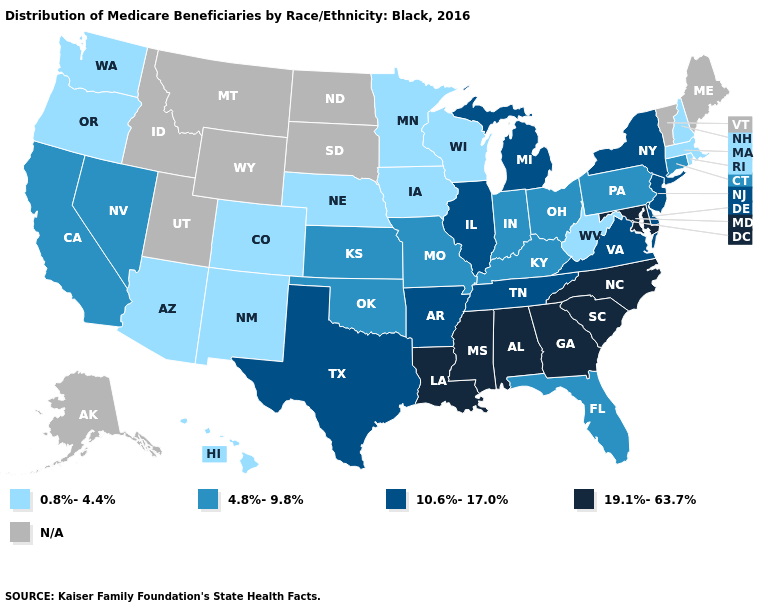Which states have the highest value in the USA?
Write a very short answer. Alabama, Georgia, Louisiana, Maryland, Mississippi, North Carolina, South Carolina. Does Arkansas have the highest value in the South?
Write a very short answer. No. Name the states that have a value in the range 19.1%-63.7%?
Short answer required. Alabama, Georgia, Louisiana, Maryland, Mississippi, North Carolina, South Carolina. What is the value of Wyoming?
Give a very brief answer. N/A. Does Arkansas have the lowest value in the South?
Give a very brief answer. No. Among the states that border Mississippi , does Arkansas have the lowest value?
Give a very brief answer. Yes. Name the states that have a value in the range 0.8%-4.4%?
Keep it brief. Arizona, Colorado, Hawaii, Iowa, Massachusetts, Minnesota, Nebraska, New Hampshire, New Mexico, Oregon, Rhode Island, Washington, West Virginia, Wisconsin. What is the highest value in the USA?
Short answer required. 19.1%-63.7%. Name the states that have a value in the range 4.8%-9.8%?
Keep it brief. California, Connecticut, Florida, Indiana, Kansas, Kentucky, Missouri, Nevada, Ohio, Oklahoma, Pennsylvania. Which states have the highest value in the USA?
Quick response, please. Alabama, Georgia, Louisiana, Maryland, Mississippi, North Carolina, South Carolina. Among the states that border Texas , does New Mexico have the lowest value?
Short answer required. Yes. What is the highest value in the USA?
Short answer required. 19.1%-63.7%. Name the states that have a value in the range N/A?
Quick response, please. Alaska, Idaho, Maine, Montana, North Dakota, South Dakota, Utah, Vermont, Wyoming. Name the states that have a value in the range N/A?
Short answer required. Alaska, Idaho, Maine, Montana, North Dakota, South Dakota, Utah, Vermont, Wyoming. Which states hav the highest value in the MidWest?
Quick response, please. Illinois, Michigan. 